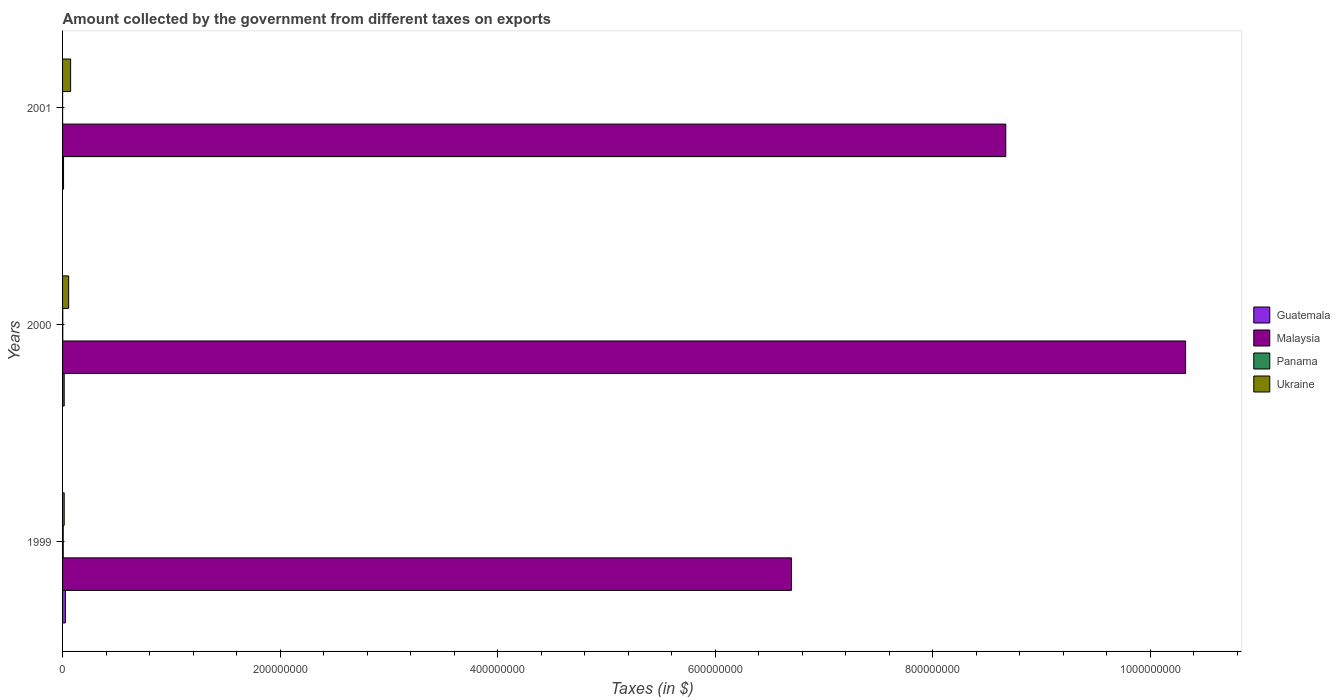How many different coloured bars are there?
Your answer should be very brief. 4. What is the label of the 3rd group of bars from the top?
Your answer should be very brief. 1999. In which year was the amount collected by the government from taxes on exports in Guatemala minimum?
Make the answer very short. 2001. What is the difference between the amount collected by the government from taxes on exports in Malaysia in 1999 and that in 2001?
Provide a short and direct response. -1.97e+08. What is the difference between the amount collected by the government from taxes on exports in Panama in 2000 and the amount collected by the government from taxes on exports in Malaysia in 2001?
Ensure brevity in your answer.  -8.67e+08. In the year 2001, what is the difference between the amount collected by the government from taxes on exports in Panama and amount collected by the government from taxes on exports in Malaysia?
Make the answer very short. -8.67e+08. What is the difference between the highest and the second highest amount collected by the government from taxes on exports in Panama?
Keep it short and to the point. 4.00e+05. What is the difference between the highest and the lowest amount collected by the government from taxes on exports in Ukraine?
Provide a succinct answer. 5.90e+06. In how many years, is the amount collected by the government from taxes on exports in Guatemala greater than the average amount collected by the government from taxes on exports in Guatemala taken over all years?
Keep it short and to the point. 1. Is the sum of the amount collected by the government from taxes on exports in Ukraine in 1999 and 2001 greater than the maximum amount collected by the government from taxes on exports in Panama across all years?
Your answer should be compact. Yes. What does the 2nd bar from the top in 1999 represents?
Ensure brevity in your answer.  Panama. What does the 4th bar from the bottom in 2000 represents?
Ensure brevity in your answer.  Ukraine. How many bars are there?
Your answer should be very brief. 12. What is the difference between two consecutive major ticks on the X-axis?
Ensure brevity in your answer.  2.00e+08. Does the graph contain grids?
Offer a very short reply. No. Where does the legend appear in the graph?
Your response must be concise. Center right. What is the title of the graph?
Provide a short and direct response. Amount collected by the government from different taxes on exports. Does "Slovak Republic" appear as one of the legend labels in the graph?
Give a very brief answer. No. What is the label or title of the X-axis?
Give a very brief answer. Taxes (in $). What is the Taxes (in $) in Guatemala in 1999?
Offer a very short reply. 2.61e+06. What is the Taxes (in $) in Malaysia in 1999?
Keep it short and to the point. 6.70e+08. What is the Taxes (in $) of Panama in 1999?
Ensure brevity in your answer.  6.00e+05. What is the Taxes (in $) of Ukraine in 1999?
Make the answer very short. 1.50e+06. What is the Taxes (in $) of Guatemala in 2000?
Make the answer very short. 1.49e+06. What is the Taxes (in $) of Malaysia in 2000?
Give a very brief answer. 1.03e+09. What is the Taxes (in $) of Panama in 2000?
Offer a very short reply. 2.00e+05. What is the Taxes (in $) of Ukraine in 2000?
Your response must be concise. 5.60e+06. What is the Taxes (in $) of Guatemala in 2001?
Ensure brevity in your answer.  9.00e+05. What is the Taxes (in $) in Malaysia in 2001?
Your answer should be compact. 8.67e+08. What is the Taxes (in $) in Ukraine in 2001?
Offer a terse response. 7.40e+06. Across all years, what is the maximum Taxes (in $) of Guatemala?
Keep it short and to the point. 2.61e+06. Across all years, what is the maximum Taxes (in $) of Malaysia?
Provide a short and direct response. 1.03e+09. Across all years, what is the maximum Taxes (in $) in Ukraine?
Your response must be concise. 7.40e+06. Across all years, what is the minimum Taxes (in $) in Guatemala?
Keep it short and to the point. 9.00e+05. Across all years, what is the minimum Taxes (in $) of Malaysia?
Keep it short and to the point. 6.70e+08. Across all years, what is the minimum Taxes (in $) of Panama?
Keep it short and to the point. 4.00e+04. Across all years, what is the minimum Taxes (in $) of Ukraine?
Provide a succinct answer. 1.50e+06. What is the total Taxes (in $) in Malaysia in the graph?
Offer a terse response. 2.57e+09. What is the total Taxes (in $) of Panama in the graph?
Give a very brief answer. 8.40e+05. What is the total Taxes (in $) in Ukraine in the graph?
Offer a very short reply. 1.45e+07. What is the difference between the Taxes (in $) in Guatemala in 1999 and that in 2000?
Provide a short and direct response. 1.12e+06. What is the difference between the Taxes (in $) in Malaysia in 1999 and that in 2000?
Provide a succinct answer. -3.62e+08. What is the difference between the Taxes (in $) of Ukraine in 1999 and that in 2000?
Your response must be concise. -4.10e+06. What is the difference between the Taxes (in $) of Guatemala in 1999 and that in 2001?
Keep it short and to the point. 1.71e+06. What is the difference between the Taxes (in $) in Malaysia in 1999 and that in 2001?
Your response must be concise. -1.97e+08. What is the difference between the Taxes (in $) of Panama in 1999 and that in 2001?
Make the answer very short. 5.60e+05. What is the difference between the Taxes (in $) of Ukraine in 1999 and that in 2001?
Make the answer very short. -5.90e+06. What is the difference between the Taxes (in $) in Guatemala in 2000 and that in 2001?
Provide a succinct answer. 5.90e+05. What is the difference between the Taxes (in $) in Malaysia in 2000 and that in 2001?
Provide a short and direct response. 1.65e+08. What is the difference between the Taxes (in $) in Ukraine in 2000 and that in 2001?
Your response must be concise. -1.80e+06. What is the difference between the Taxes (in $) in Guatemala in 1999 and the Taxes (in $) in Malaysia in 2000?
Offer a very short reply. -1.03e+09. What is the difference between the Taxes (in $) in Guatemala in 1999 and the Taxes (in $) in Panama in 2000?
Offer a terse response. 2.41e+06. What is the difference between the Taxes (in $) in Guatemala in 1999 and the Taxes (in $) in Ukraine in 2000?
Ensure brevity in your answer.  -2.99e+06. What is the difference between the Taxes (in $) in Malaysia in 1999 and the Taxes (in $) in Panama in 2000?
Your response must be concise. 6.70e+08. What is the difference between the Taxes (in $) in Malaysia in 1999 and the Taxes (in $) in Ukraine in 2000?
Your answer should be very brief. 6.64e+08. What is the difference between the Taxes (in $) of Panama in 1999 and the Taxes (in $) of Ukraine in 2000?
Your answer should be compact. -5.00e+06. What is the difference between the Taxes (in $) of Guatemala in 1999 and the Taxes (in $) of Malaysia in 2001?
Your answer should be compact. -8.64e+08. What is the difference between the Taxes (in $) in Guatemala in 1999 and the Taxes (in $) in Panama in 2001?
Your answer should be compact. 2.57e+06. What is the difference between the Taxes (in $) of Guatemala in 1999 and the Taxes (in $) of Ukraine in 2001?
Ensure brevity in your answer.  -4.79e+06. What is the difference between the Taxes (in $) in Malaysia in 1999 and the Taxes (in $) in Panama in 2001?
Give a very brief answer. 6.70e+08. What is the difference between the Taxes (in $) in Malaysia in 1999 and the Taxes (in $) in Ukraine in 2001?
Offer a very short reply. 6.63e+08. What is the difference between the Taxes (in $) of Panama in 1999 and the Taxes (in $) of Ukraine in 2001?
Offer a terse response. -6.80e+06. What is the difference between the Taxes (in $) in Guatemala in 2000 and the Taxes (in $) in Malaysia in 2001?
Provide a succinct answer. -8.66e+08. What is the difference between the Taxes (in $) in Guatemala in 2000 and the Taxes (in $) in Panama in 2001?
Give a very brief answer. 1.45e+06. What is the difference between the Taxes (in $) of Guatemala in 2000 and the Taxes (in $) of Ukraine in 2001?
Your answer should be very brief. -5.91e+06. What is the difference between the Taxes (in $) in Malaysia in 2000 and the Taxes (in $) in Panama in 2001?
Your answer should be very brief. 1.03e+09. What is the difference between the Taxes (in $) of Malaysia in 2000 and the Taxes (in $) of Ukraine in 2001?
Give a very brief answer. 1.02e+09. What is the difference between the Taxes (in $) of Panama in 2000 and the Taxes (in $) of Ukraine in 2001?
Make the answer very short. -7.20e+06. What is the average Taxes (in $) of Guatemala per year?
Give a very brief answer. 1.67e+06. What is the average Taxes (in $) in Malaysia per year?
Provide a succinct answer. 8.56e+08. What is the average Taxes (in $) in Ukraine per year?
Your answer should be very brief. 4.83e+06. In the year 1999, what is the difference between the Taxes (in $) of Guatemala and Taxes (in $) of Malaysia?
Provide a succinct answer. -6.67e+08. In the year 1999, what is the difference between the Taxes (in $) in Guatemala and Taxes (in $) in Panama?
Your answer should be compact. 2.01e+06. In the year 1999, what is the difference between the Taxes (in $) in Guatemala and Taxes (in $) in Ukraine?
Ensure brevity in your answer.  1.11e+06. In the year 1999, what is the difference between the Taxes (in $) in Malaysia and Taxes (in $) in Panama?
Keep it short and to the point. 6.69e+08. In the year 1999, what is the difference between the Taxes (in $) in Malaysia and Taxes (in $) in Ukraine?
Provide a succinct answer. 6.68e+08. In the year 1999, what is the difference between the Taxes (in $) of Panama and Taxes (in $) of Ukraine?
Your response must be concise. -9.00e+05. In the year 2000, what is the difference between the Taxes (in $) in Guatemala and Taxes (in $) in Malaysia?
Offer a very short reply. -1.03e+09. In the year 2000, what is the difference between the Taxes (in $) of Guatemala and Taxes (in $) of Panama?
Provide a succinct answer. 1.29e+06. In the year 2000, what is the difference between the Taxes (in $) in Guatemala and Taxes (in $) in Ukraine?
Make the answer very short. -4.11e+06. In the year 2000, what is the difference between the Taxes (in $) of Malaysia and Taxes (in $) of Panama?
Provide a succinct answer. 1.03e+09. In the year 2000, what is the difference between the Taxes (in $) in Malaysia and Taxes (in $) in Ukraine?
Your answer should be very brief. 1.03e+09. In the year 2000, what is the difference between the Taxes (in $) in Panama and Taxes (in $) in Ukraine?
Ensure brevity in your answer.  -5.40e+06. In the year 2001, what is the difference between the Taxes (in $) in Guatemala and Taxes (in $) in Malaysia?
Your answer should be very brief. -8.66e+08. In the year 2001, what is the difference between the Taxes (in $) of Guatemala and Taxes (in $) of Panama?
Your answer should be very brief. 8.60e+05. In the year 2001, what is the difference between the Taxes (in $) in Guatemala and Taxes (in $) in Ukraine?
Your answer should be very brief. -6.50e+06. In the year 2001, what is the difference between the Taxes (in $) in Malaysia and Taxes (in $) in Panama?
Your answer should be compact. 8.67e+08. In the year 2001, what is the difference between the Taxes (in $) in Malaysia and Taxes (in $) in Ukraine?
Offer a very short reply. 8.60e+08. In the year 2001, what is the difference between the Taxes (in $) in Panama and Taxes (in $) in Ukraine?
Keep it short and to the point. -7.36e+06. What is the ratio of the Taxes (in $) of Guatemala in 1999 to that in 2000?
Provide a short and direct response. 1.75. What is the ratio of the Taxes (in $) in Malaysia in 1999 to that in 2000?
Ensure brevity in your answer.  0.65. What is the ratio of the Taxes (in $) of Panama in 1999 to that in 2000?
Provide a succinct answer. 3. What is the ratio of the Taxes (in $) in Ukraine in 1999 to that in 2000?
Make the answer very short. 0.27. What is the ratio of the Taxes (in $) of Malaysia in 1999 to that in 2001?
Your response must be concise. 0.77. What is the ratio of the Taxes (in $) in Ukraine in 1999 to that in 2001?
Provide a succinct answer. 0.2. What is the ratio of the Taxes (in $) of Guatemala in 2000 to that in 2001?
Your response must be concise. 1.66. What is the ratio of the Taxes (in $) of Malaysia in 2000 to that in 2001?
Provide a short and direct response. 1.19. What is the ratio of the Taxes (in $) of Ukraine in 2000 to that in 2001?
Ensure brevity in your answer.  0.76. What is the difference between the highest and the second highest Taxes (in $) in Guatemala?
Ensure brevity in your answer.  1.12e+06. What is the difference between the highest and the second highest Taxes (in $) of Malaysia?
Offer a terse response. 1.65e+08. What is the difference between the highest and the second highest Taxes (in $) of Panama?
Provide a short and direct response. 4.00e+05. What is the difference between the highest and the second highest Taxes (in $) in Ukraine?
Your response must be concise. 1.80e+06. What is the difference between the highest and the lowest Taxes (in $) in Guatemala?
Your answer should be compact. 1.71e+06. What is the difference between the highest and the lowest Taxes (in $) in Malaysia?
Your answer should be very brief. 3.62e+08. What is the difference between the highest and the lowest Taxes (in $) in Panama?
Your answer should be very brief. 5.60e+05. What is the difference between the highest and the lowest Taxes (in $) in Ukraine?
Your answer should be very brief. 5.90e+06. 